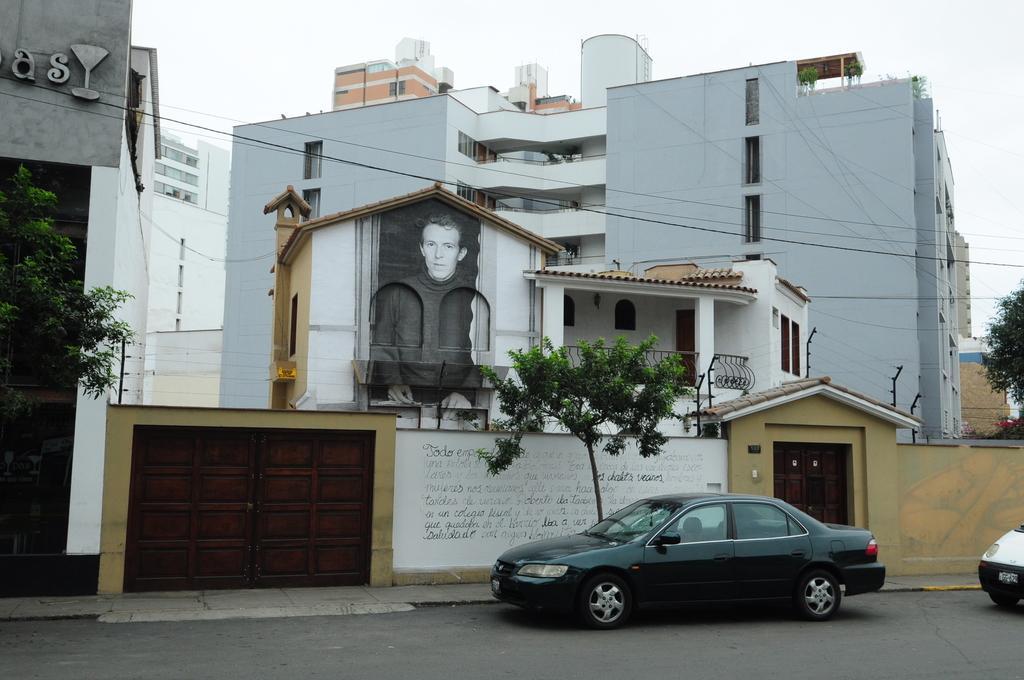Could you give a brief overview of what you see in this image? In this picture I can see vehicles on the road. There are buildings, trees, and in the background there is the sky. 